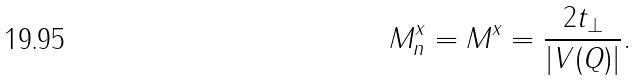Convert formula to latex. <formula><loc_0><loc_0><loc_500><loc_500>M ^ { x } _ { n } = M ^ { x } = \frac { 2 t _ { \perp } } { | V ( { Q } ) | } .</formula> 